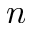<formula> <loc_0><loc_0><loc_500><loc_500>n</formula> 